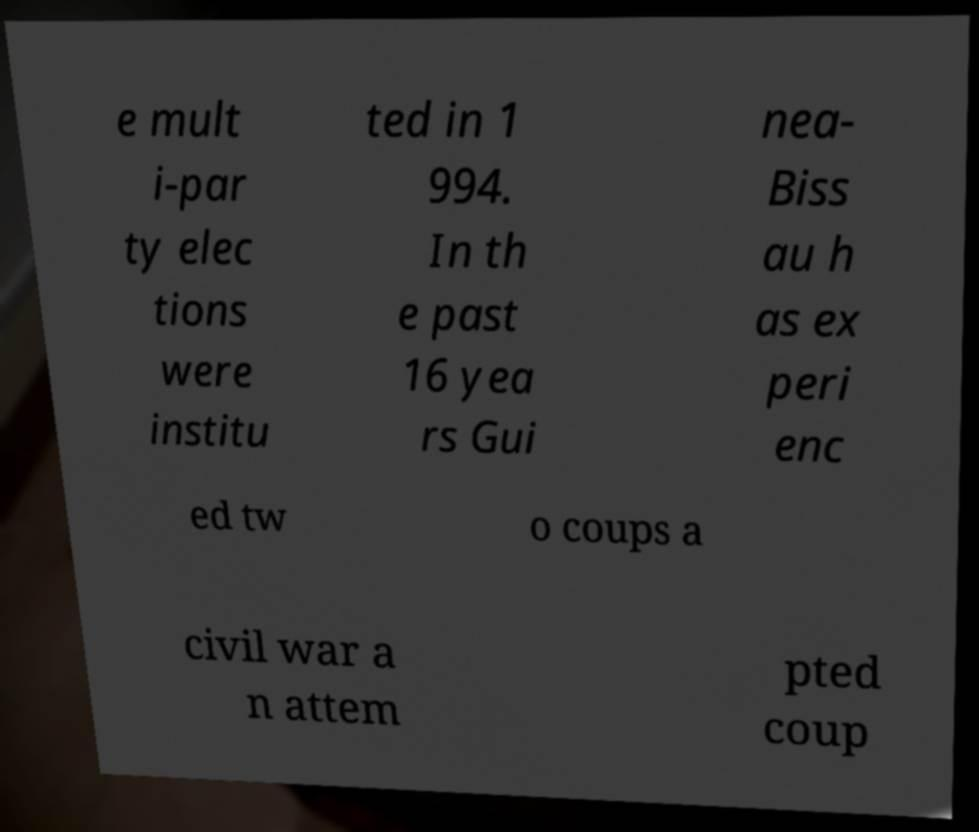I need the written content from this picture converted into text. Can you do that? e mult i-par ty elec tions were institu ted in 1 994. In th e past 16 yea rs Gui nea- Biss au h as ex peri enc ed tw o coups a civil war a n attem pted coup 